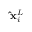<formula> <loc_0><loc_0><loc_500><loc_500>\hat { x } _ { i } ^ { L }</formula> 